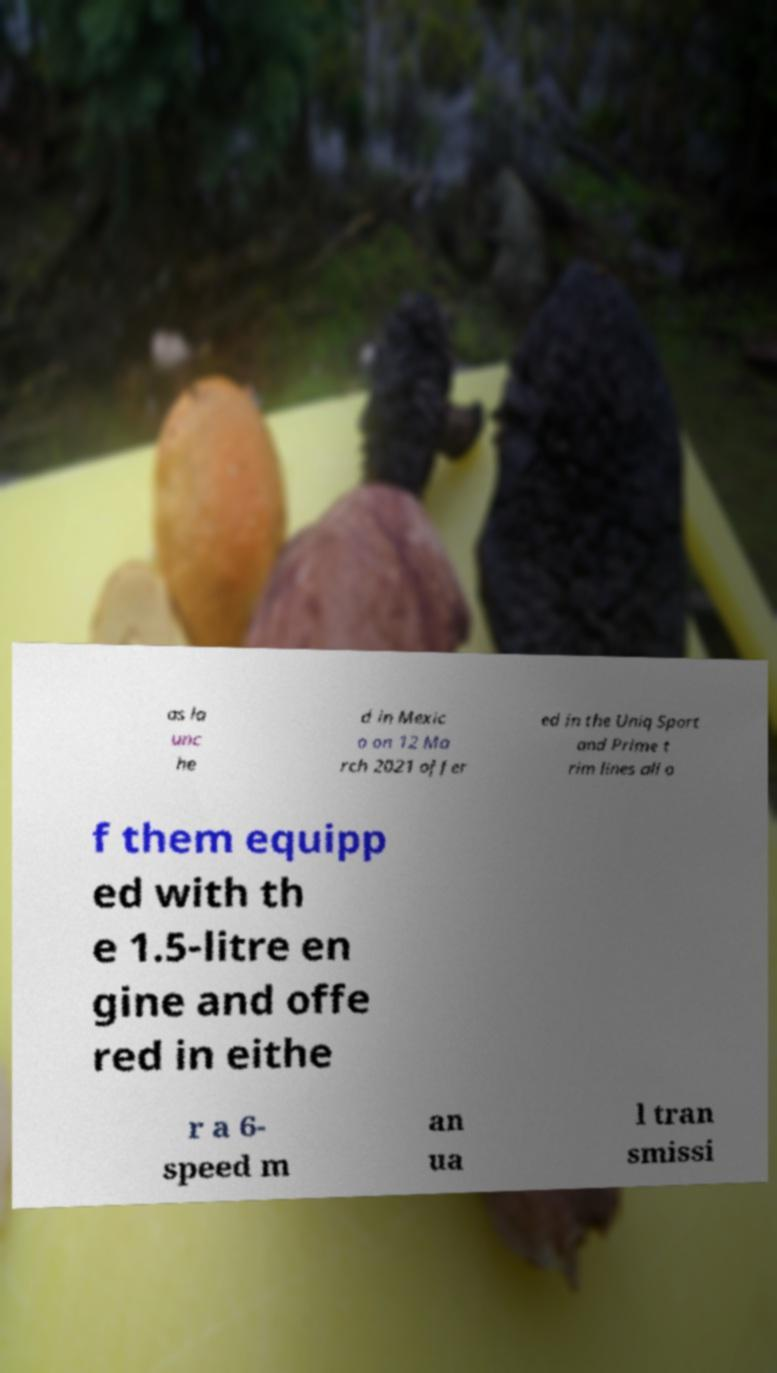Please read and relay the text visible in this image. What does it say? as la unc he d in Mexic o on 12 Ma rch 2021 offer ed in the Uniq Sport and Prime t rim lines all o f them equipp ed with th e 1.5-litre en gine and offe red in eithe r a 6- speed m an ua l tran smissi 